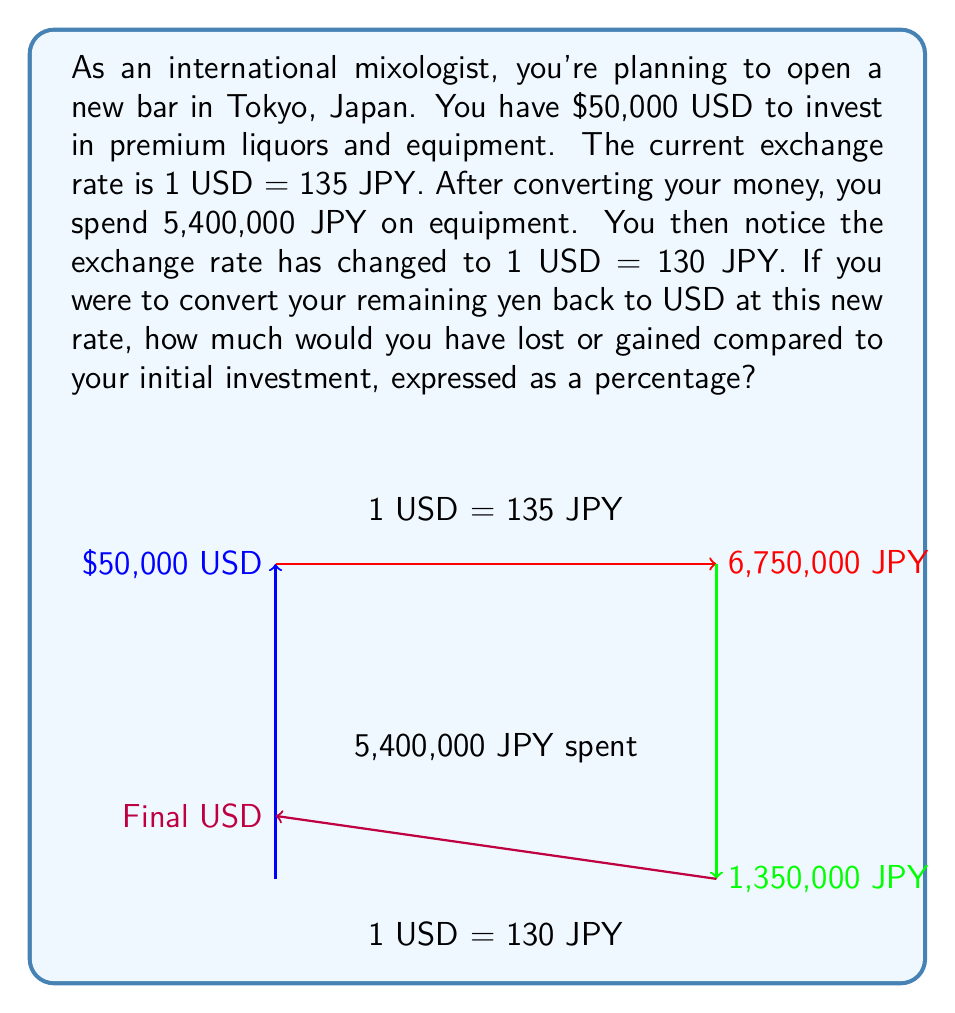Help me with this question. Let's break this down step-by-step:

1) First, convert $50,000 USD to JPY at the initial rate:
   $$50,000 \times 135 = 6,750,000 \text{ JPY}$$

2) After spending 5,400,000 JPY on equipment, you're left with:
   $$6,750,000 - 5,400,000 = 1,350,000 \text{ JPY}$$

3) Now, convert the remaining 1,350,000 JPY back to USD at the new rate:
   $$1,350,000 \div 130 = 10,384.62 \text{ USD}$$

4) Calculate the difference from the initial investment:
   $$10,384.62 - 50,000 = -39,615.38 \text{ USD}$$

5) Express this as a percentage of the initial investment:
   $$\frac{-39,615.38}{50,000} \times 100 = -79.23\%$$

The negative value indicates a loss.
Answer: -79.23% 